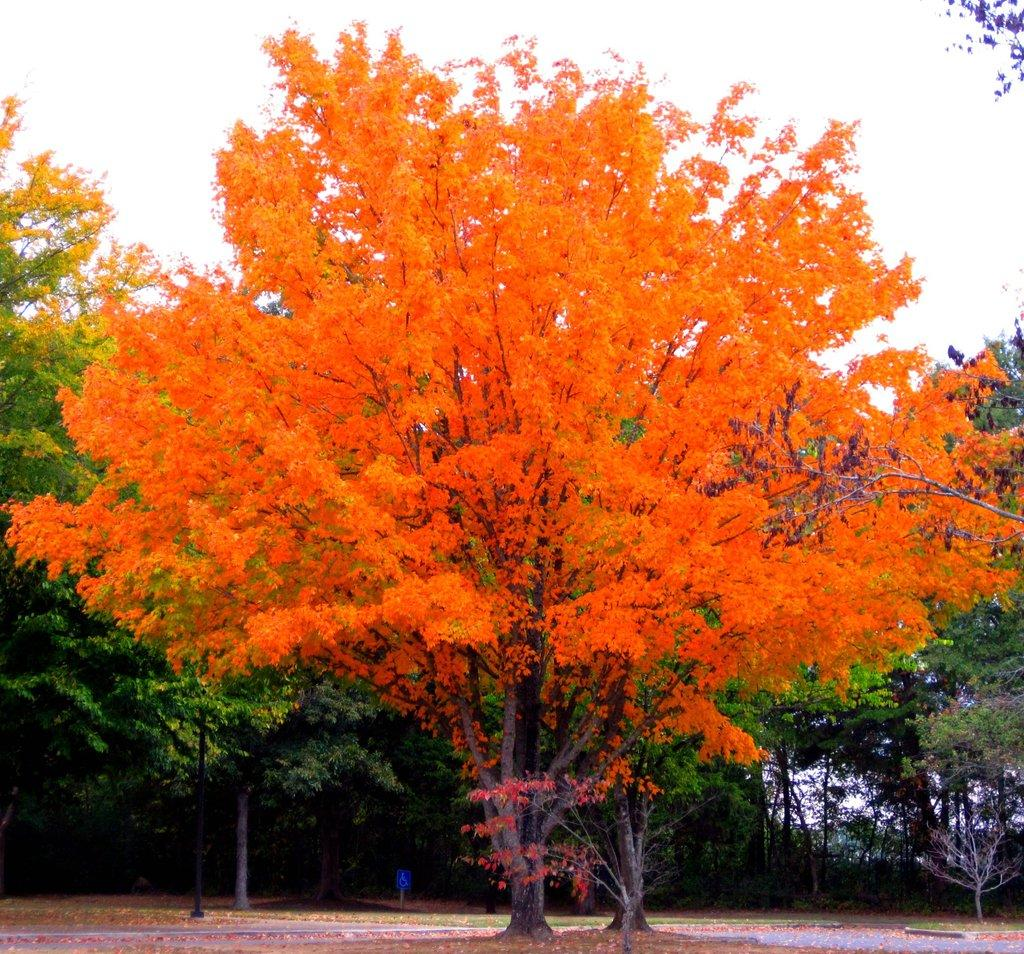What type of vegetation can be seen in the image? There are trees in the image. What object is present in the image that is typically used for supporting or holding something? There is a pole in the image. What part of the natural environment is visible in the image? The sky is visible in the image. How many clams can be seen hanging from the pole in the image? There are no clams present in the image; it features trees and a pole. What type of curve can be observed in the sky in the image? The sky in the image is not described as having any curves; it is simply visible. 